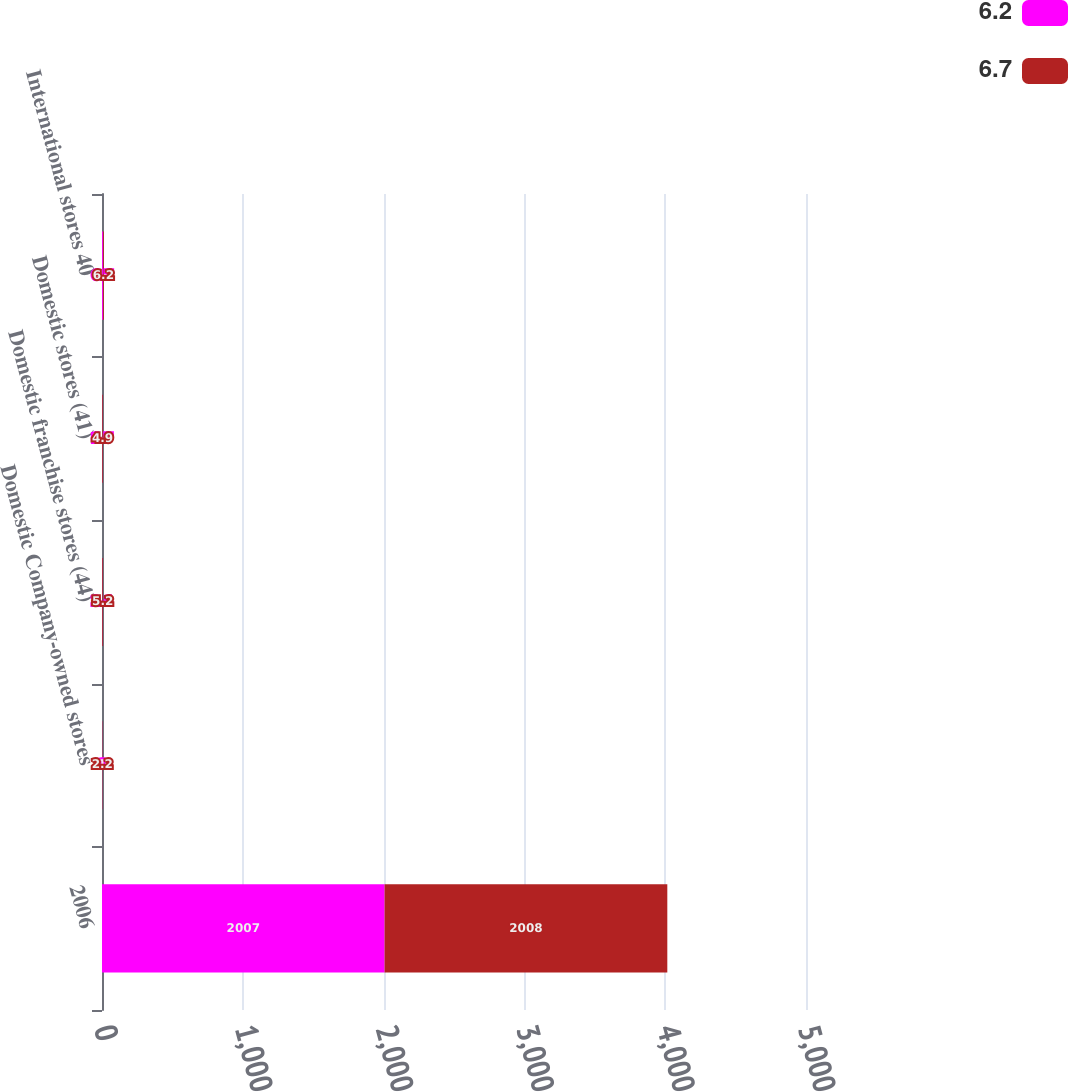<chart> <loc_0><loc_0><loc_500><loc_500><stacked_bar_chart><ecel><fcel>2006<fcel>Domestic Company-owned stores<fcel>Domestic franchise stores (44)<fcel>Domestic stores (41)<fcel>International stores 40<nl><fcel>6.2<fcel>2007<fcel>1<fcel>2.1<fcel>1.7<fcel>6.7<nl><fcel>6.7<fcel>2008<fcel>2.2<fcel>5.2<fcel>4.9<fcel>6.2<nl></chart> 